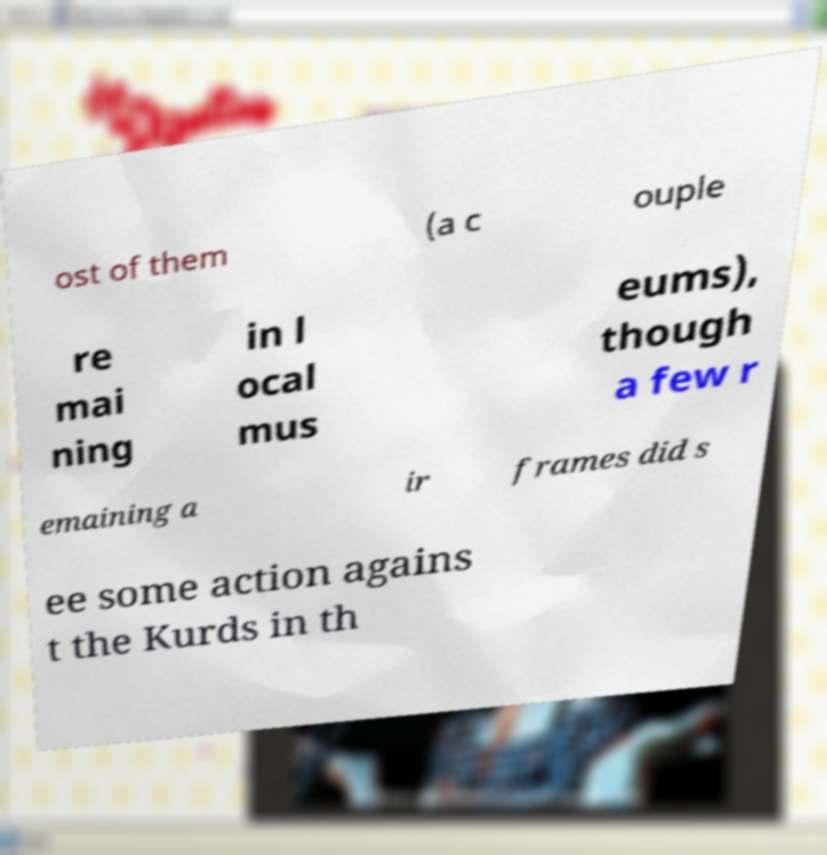There's text embedded in this image that I need extracted. Can you transcribe it verbatim? ost of them (a c ouple re mai ning in l ocal mus eums), though a few r emaining a ir frames did s ee some action agains t the Kurds in th 